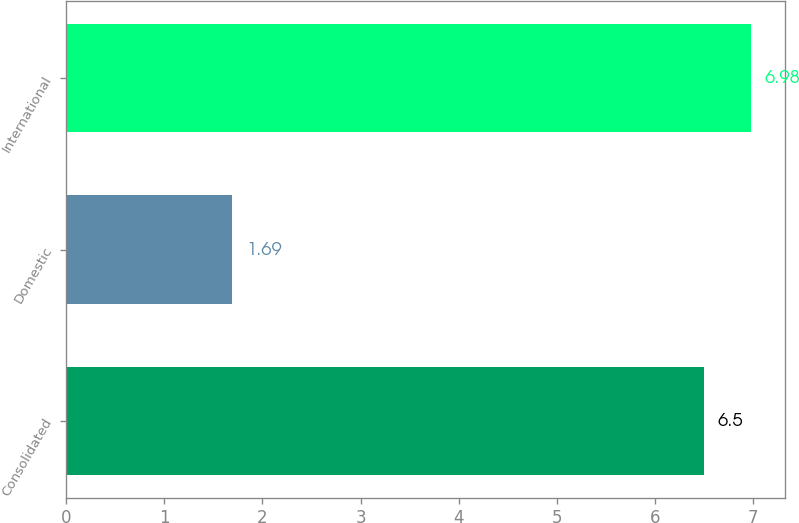<chart> <loc_0><loc_0><loc_500><loc_500><bar_chart><fcel>Consolidated<fcel>Domestic<fcel>International<nl><fcel>6.5<fcel>1.69<fcel>6.98<nl></chart> 